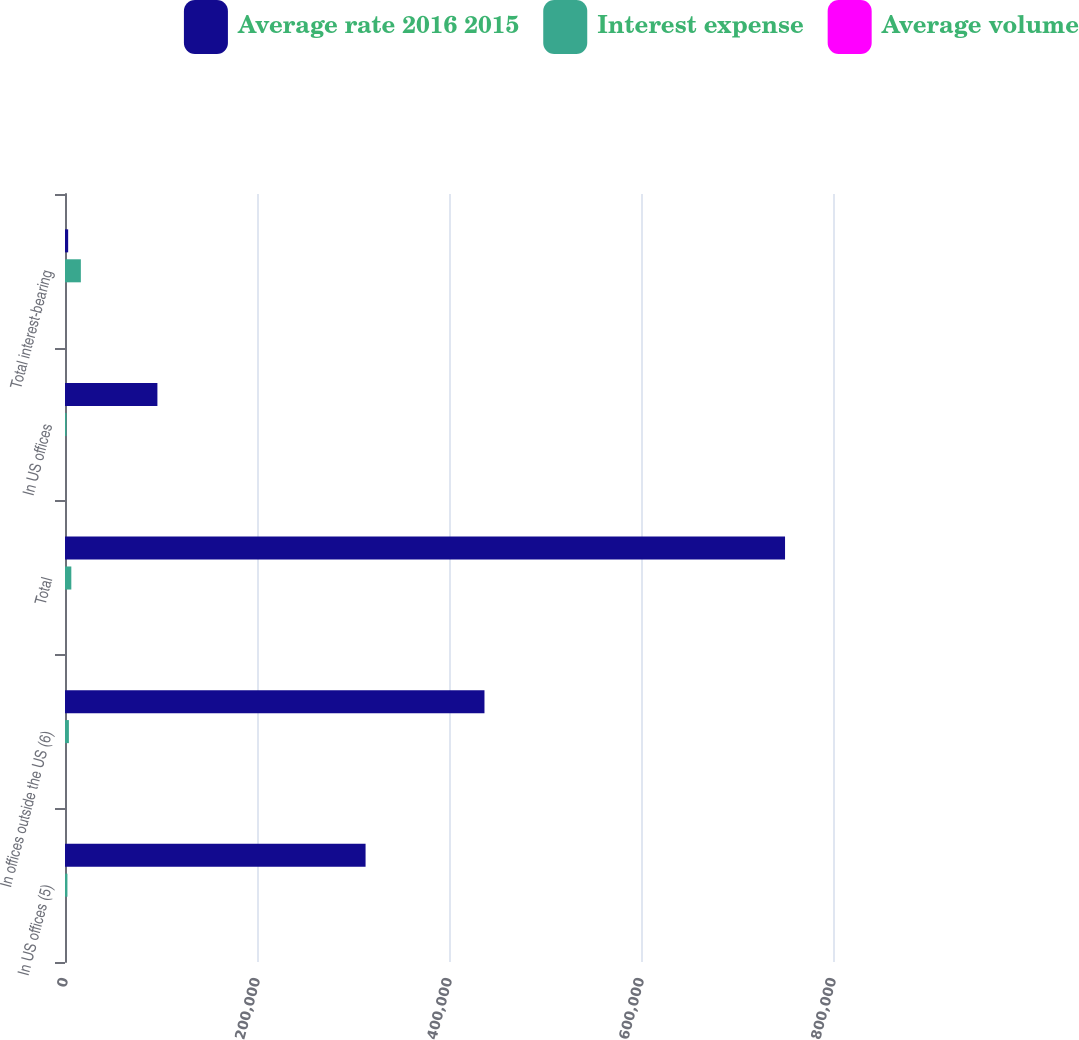Convert chart. <chart><loc_0><loc_0><loc_500><loc_500><stacked_bar_chart><ecel><fcel>In US offices (5)<fcel>In offices outside the US (6)<fcel>Total<fcel>In US offices<fcel>Total interest-bearing<nl><fcel>Average rate 2016 2015<fcel>313094<fcel>436949<fcel>750043<fcel>96258<fcel>3293<nl><fcel>Interest expense<fcel>2530<fcel>4056<fcel>6586<fcel>1574<fcel>16517<nl><fcel>Average volume<fcel>0.81<fcel>0.93<fcel>0.88<fcel>1.64<fcel>1.28<nl></chart> 